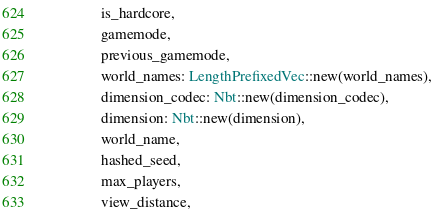<code> <loc_0><loc_0><loc_500><loc_500><_Rust_>                is_hardcore,
                gamemode,
                previous_gamemode,
                world_names: LengthPrefixedVec::new(world_names),
                dimension_codec: Nbt::new(dimension_codec),
                dimension: Nbt::new(dimension),
                world_name,
                hashed_seed,
                max_players,
                view_distance,</code> 